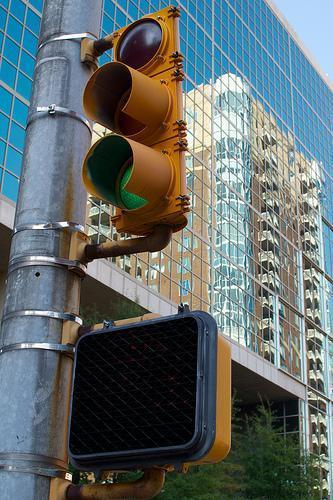How many traffic lights are pictured?
Give a very brief answer. 1. 